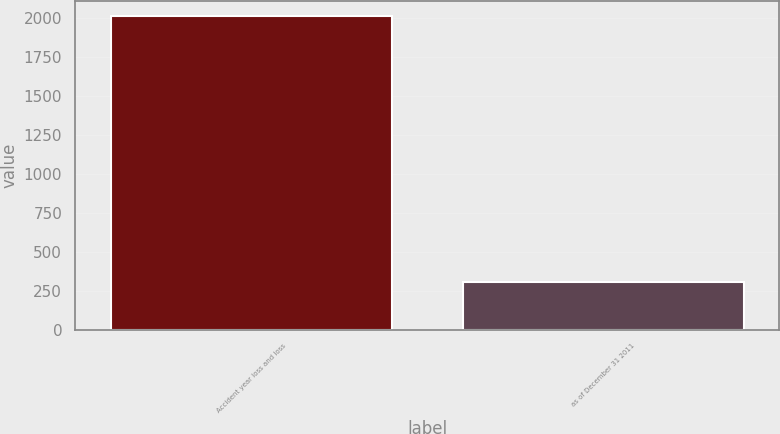Convert chart to OTSL. <chart><loc_0><loc_0><loc_500><loc_500><bar_chart><fcel>Accident year loss and loss<fcel>as of December 31 2011<nl><fcel>2011<fcel>307<nl></chart> 